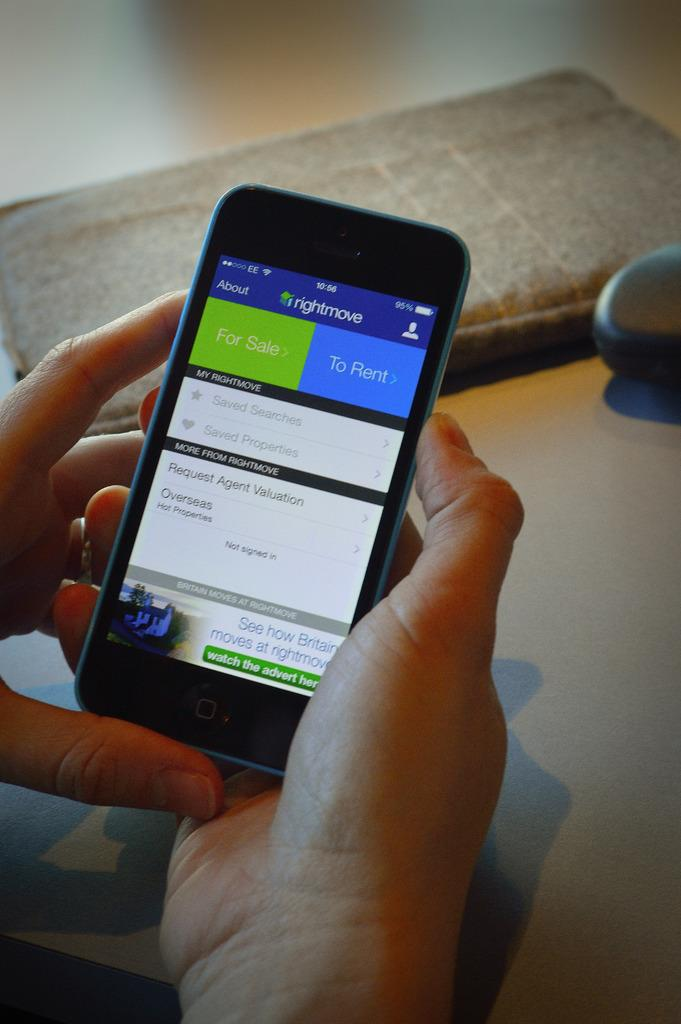What is the person in the image holding? The person is holding a mobile in the image. What can be seen in the background of the image? There are objects on a surface visible in the background of the image. What type of needle can be seen piercing the wall in the image? There is no needle or wall present in the image. What kind of pest is visible on the objects in the background of the image? There are no pests visible on the objects in the background of the image. 